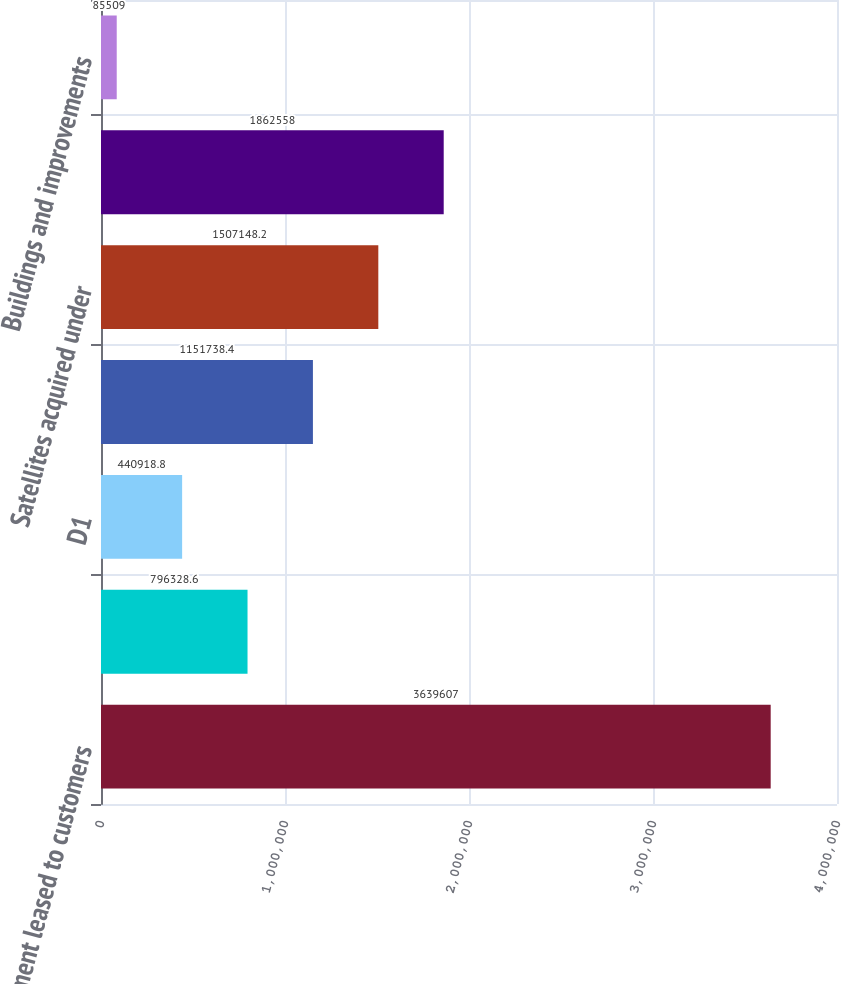Convert chart. <chart><loc_0><loc_0><loc_500><loc_500><bar_chart><fcel>Equipment leased to customers<fcel>EchoStar XV<fcel>D1<fcel>T1<fcel>Satellites acquired under<fcel>Furniture fixtures equipment<fcel>Buildings and improvements<nl><fcel>3.63961e+06<fcel>796329<fcel>440919<fcel>1.15174e+06<fcel>1.50715e+06<fcel>1.86256e+06<fcel>85509<nl></chart> 